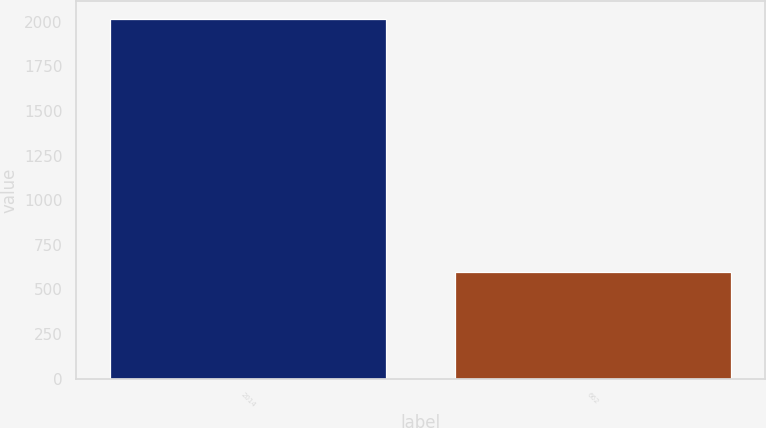<chart> <loc_0><loc_0><loc_500><loc_500><bar_chart><fcel>2014<fcel>662<nl><fcel>2013<fcel>595<nl></chart> 